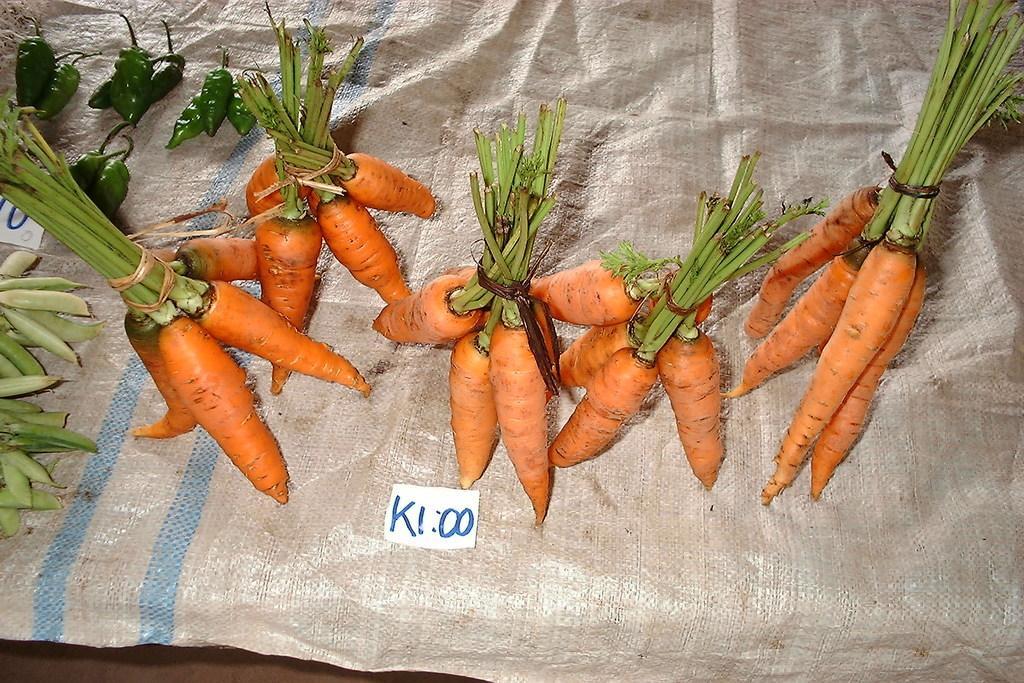Can you describe this image briefly? In this picture I can see the carrots in the middle, at the bottom there is the text. On the left side I can see the chillies and peas. 